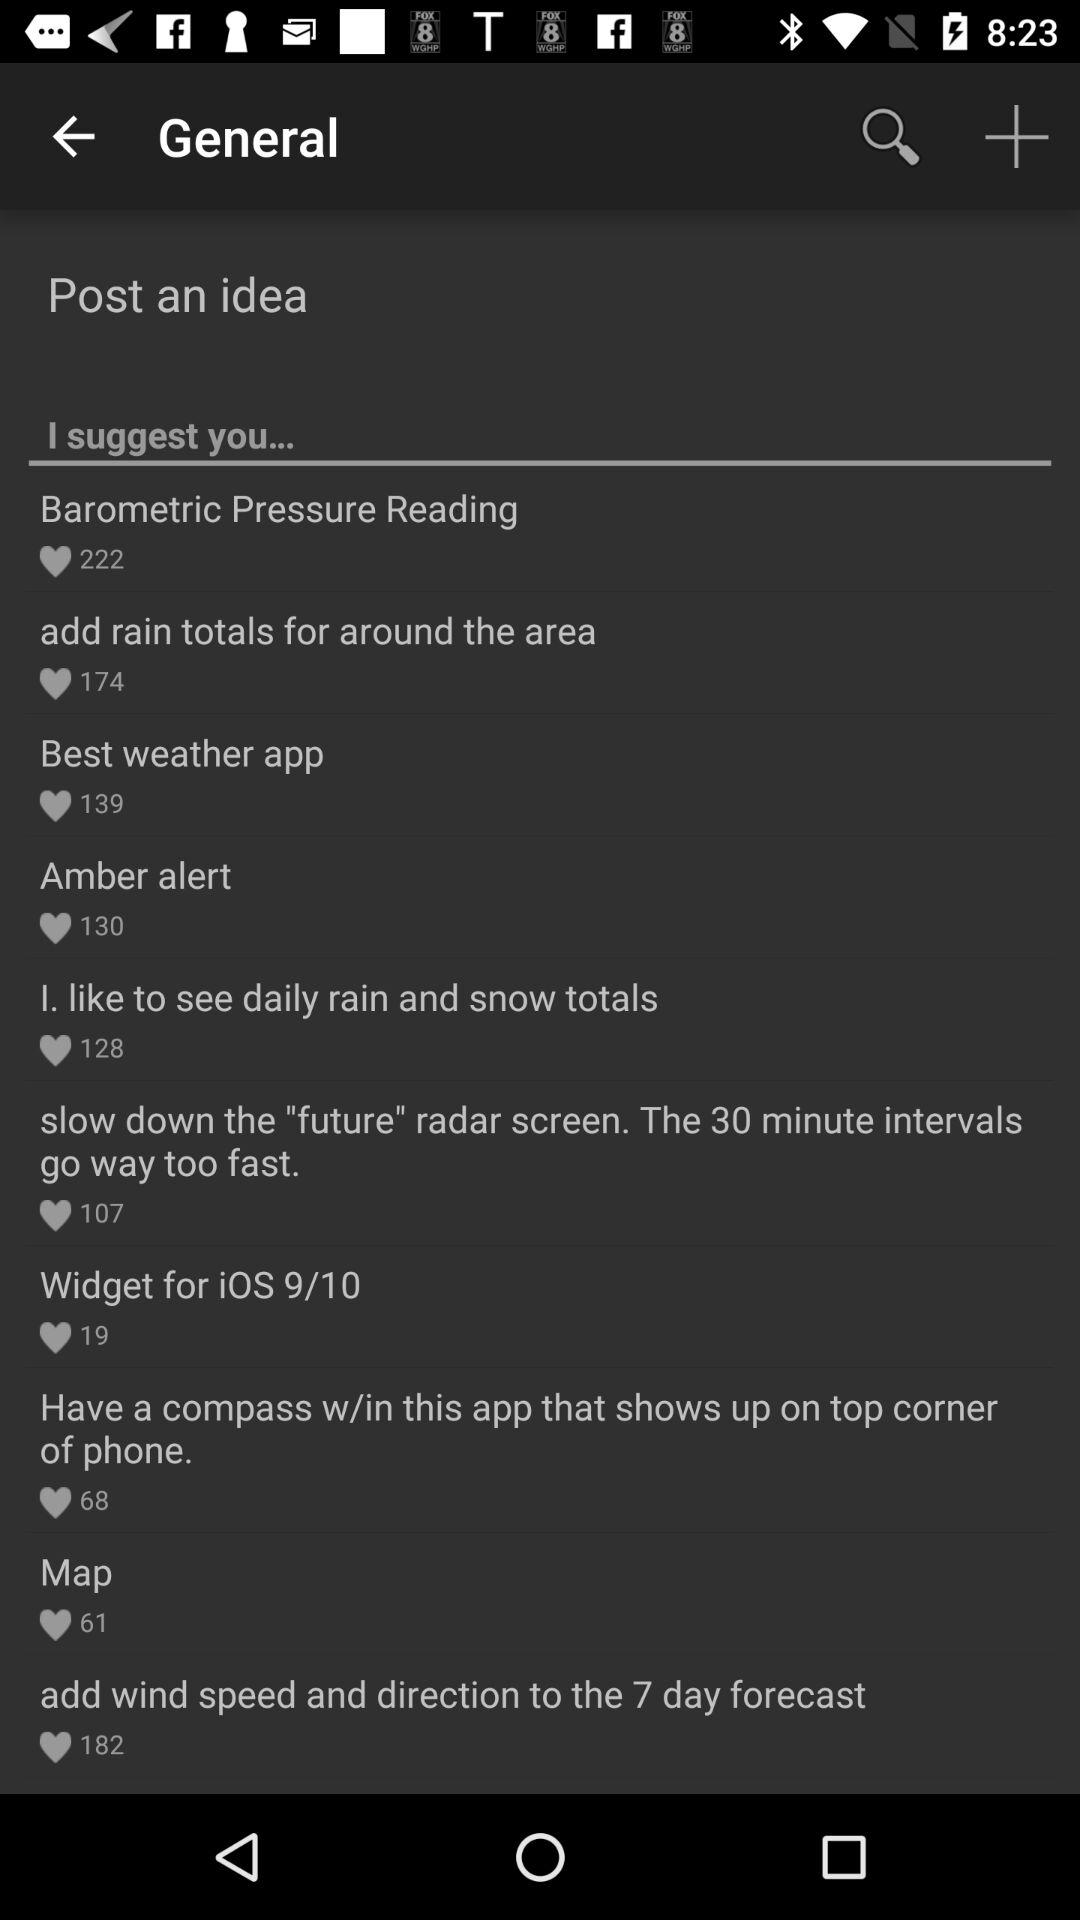What is the count of likes of "Best weather app"? The count of likes of "Best weather app" is 139. 